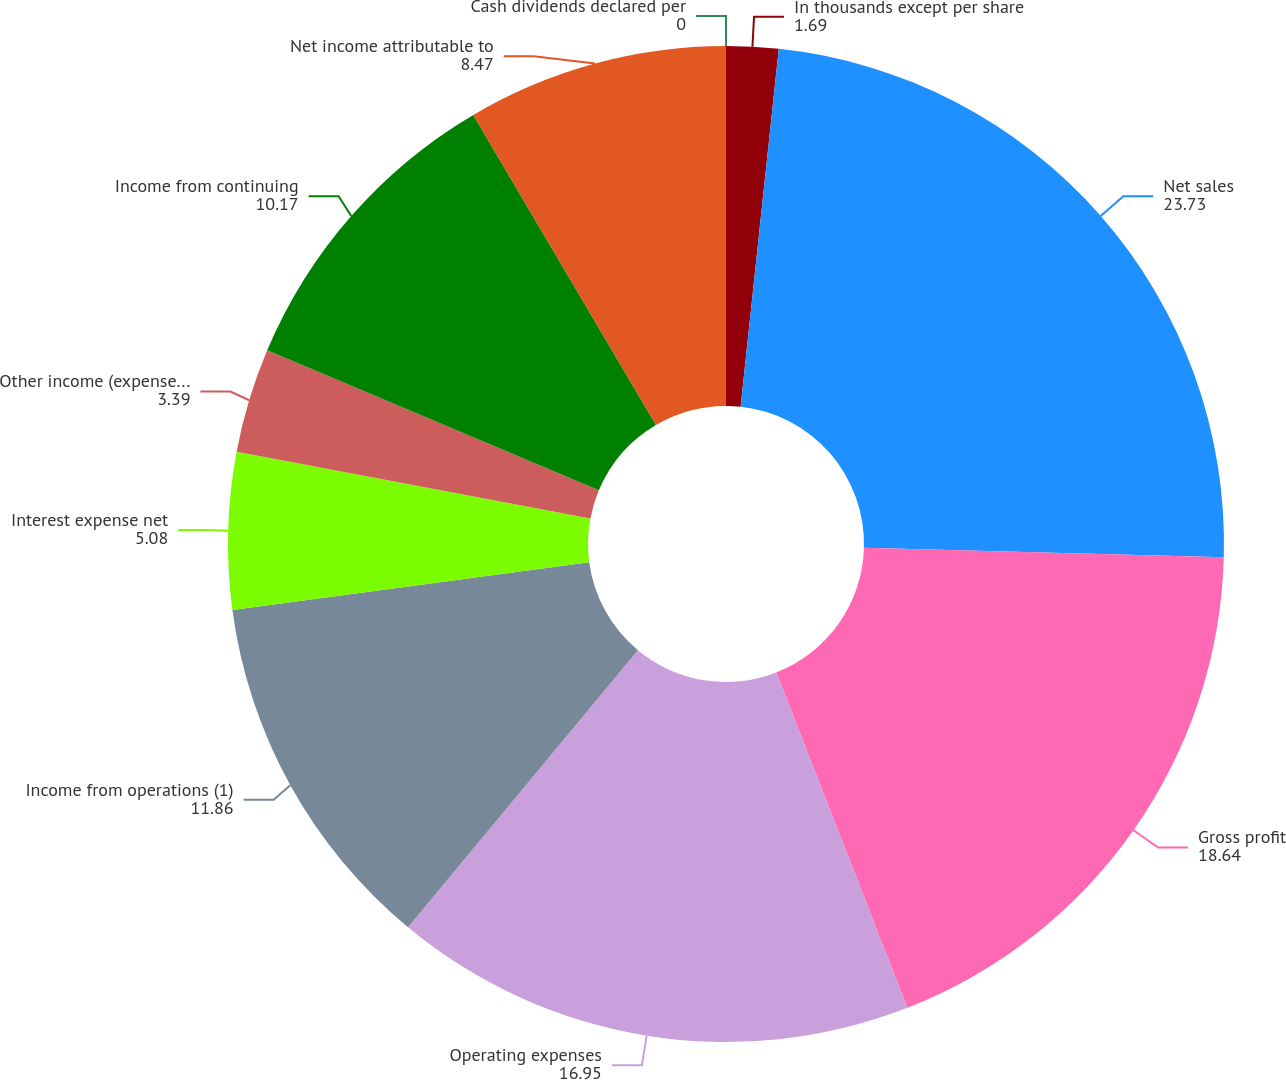<chart> <loc_0><loc_0><loc_500><loc_500><pie_chart><fcel>In thousands except per share<fcel>Net sales<fcel>Gross profit<fcel>Operating expenses<fcel>Income from operations (1)<fcel>Interest expense net<fcel>Other income (expense) net<fcel>Income from continuing<fcel>Net income attributable to<fcel>Cash dividends declared per<nl><fcel>1.69%<fcel>23.73%<fcel>18.64%<fcel>16.95%<fcel>11.86%<fcel>5.08%<fcel>3.39%<fcel>10.17%<fcel>8.47%<fcel>0.0%<nl></chart> 